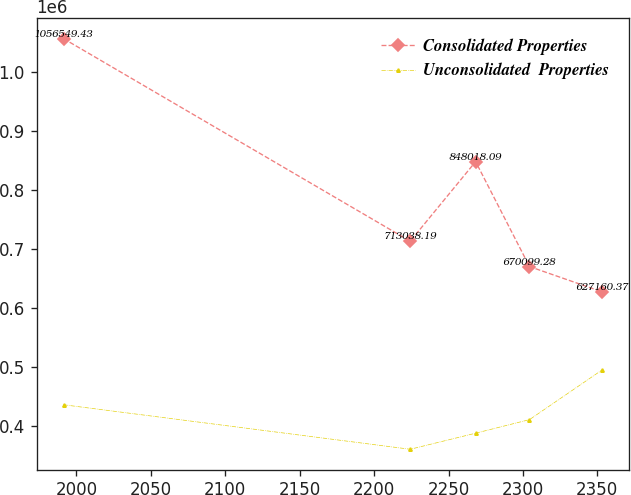<chart> <loc_0><loc_0><loc_500><loc_500><line_chart><ecel><fcel>Consolidated Properties<fcel>Unconsolidated  Properties<nl><fcel>1991.29<fcel>1.05655e+06<fcel>435854<nl><fcel>2224.26<fcel>713038<fcel>360391<nl><fcel>2268.22<fcel>848018<fcel>387626<nl><fcel>2304.42<fcel>670099<fcel>410629<nl><fcel>2353.31<fcel>627160<fcel>495018<nl></chart> 